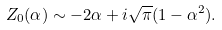Convert formula to latex. <formula><loc_0><loc_0><loc_500><loc_500>Z _ { 0 } ( \alpha ) \sim - 2 \alpha + i \sqrt { \pi } ( 1 - \alpha ^ { 2 } ) .</formula> 